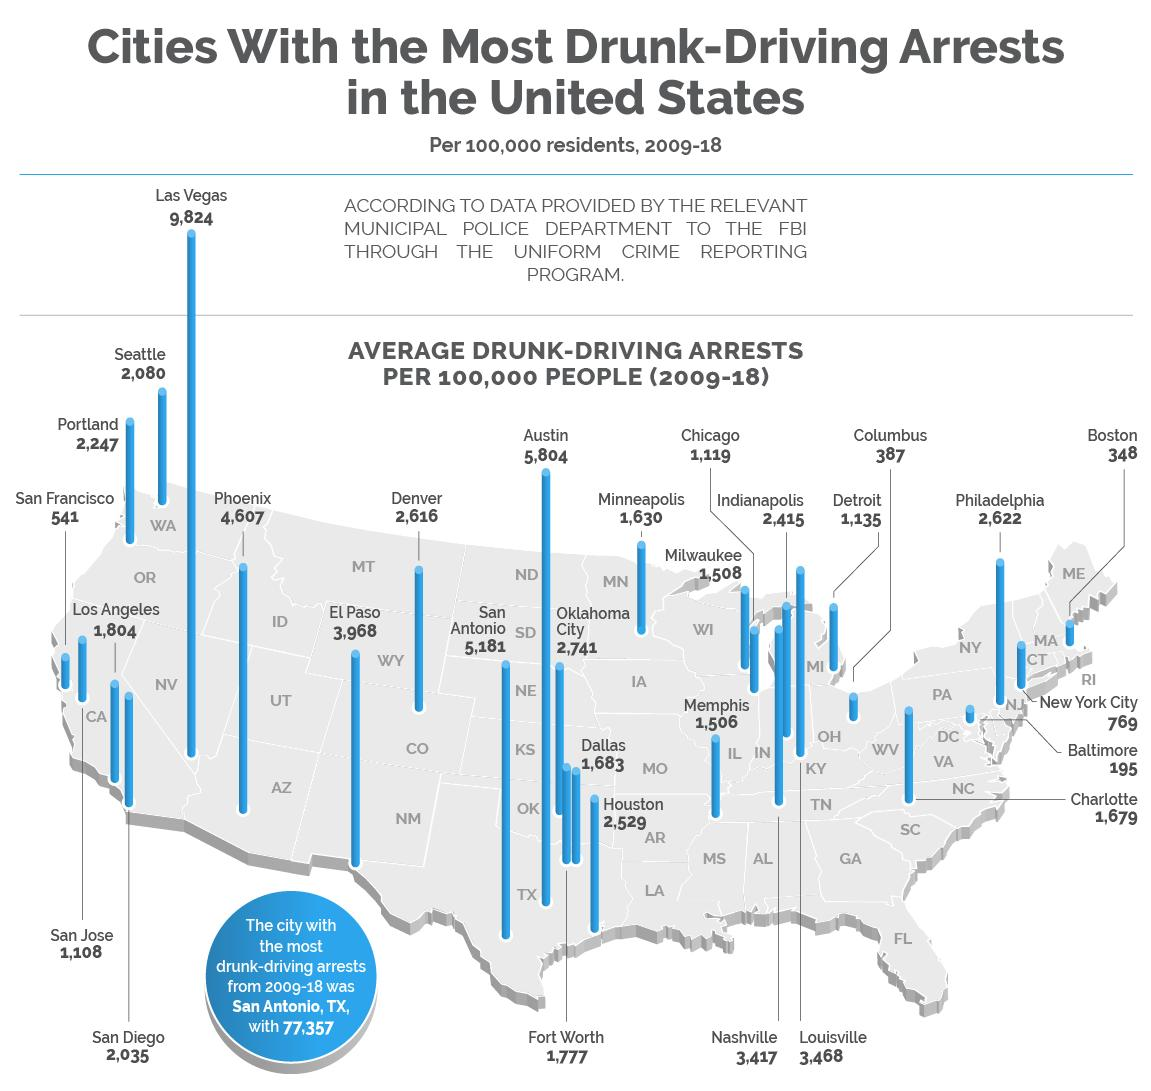Point out several critical features in this image. From 2009 to 2018, the average number of drunk-driving arrests per 100,000 people in Columbus was 387. Baltimore has the least number of drunk-driven arrests from 2009 to 2018 among all cities in the United States. The United States recorded a maximum number of drunk driving arrests from 2009 to 2018, which was 77,357. Boston has recorded the second lowest number of drunk-driven arrests from 2009 to 2018 among all cities in the United States. According to data from 2009 to 2018 in the United States, San Antonio, Texas has the highest number of drunk-driven arrests. 